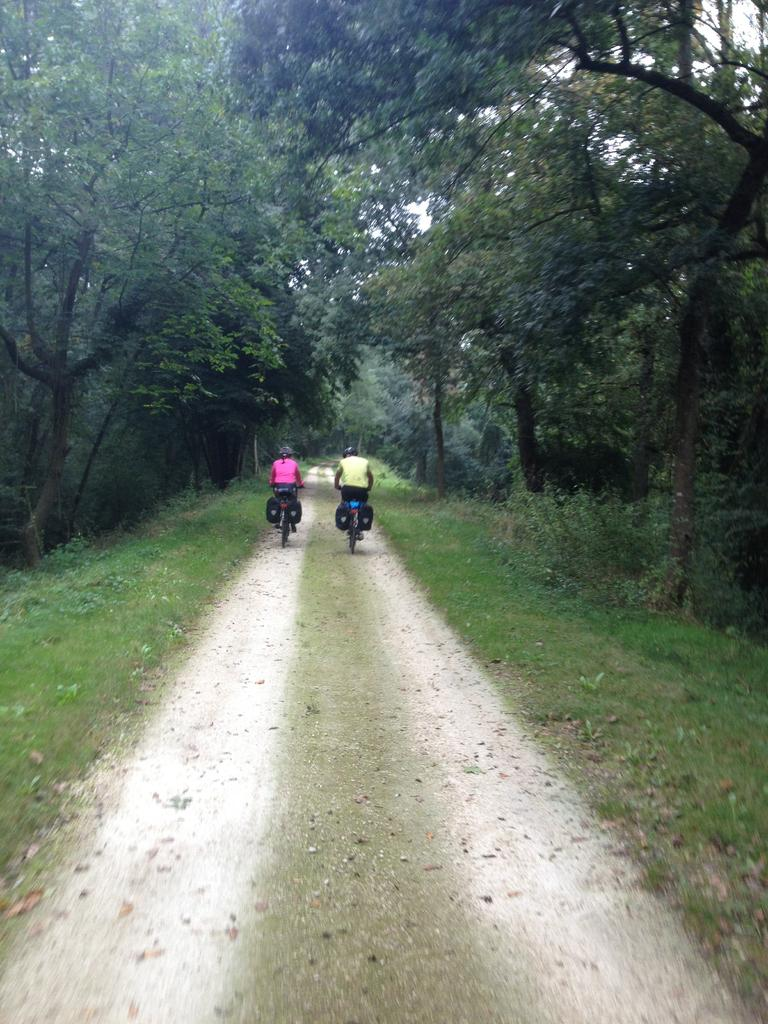How many people are in the image? There are two people in the image. What are the people doing in the image? The people are riding bicycles. What type of vegetation can be seen in the image? There are trees in the image. What is visible at the top of the image? The sky is visible at the top of the image. What type of terrain is visible in the image? There is grass in the image, and the ground is visible at the bottom of the image. What type of seat can be seen on the tiger in the image? There is no tiger or seat present in the image. What is the purpose of the competition in the image? There is no competition present in the image. 